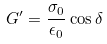Convert formula to latex. <formula><loc_0><loc_0><loc_500><loc_500>G ^ { \prime } = \frac { \sigma _ { 0 } } { \epsilon _ { 0 } } \cos \delta</formula> 